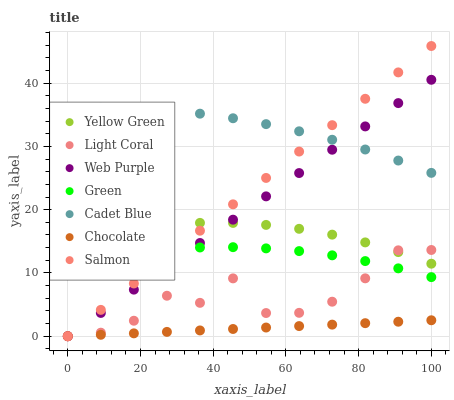Does Chocolate have the minimum area under the curve?
Answer yes or no. Yes. Does Cadet Blue have the maximum area under the curve?
Answer yes or no. Yes. Does Yellow Green have the minimum area under the curve?
Answer yes or no. No. Does Yellow Green have the maximum area under the curve?
Answer yes or no. No. Is Chocolate the smoothest?
Answer yes or no. Yes. Is Light Coral the roughest?
Answer yes or no. Yes. Is Yellow Green the smoothest?
Answer yes or no. No. Is Yellow Green the roughest?
Answer yes or no. No. Does Salmon have the lowest value?
Answer yes or no. Yes. Does Yellow Green have the lowest value?
Answer yes or no. No. Does Salmon have the highest value?
Answer yes or no. Yes. Does Yellow Green have the highest value?
Answer yes or no. No. Is Green less than Cadet Blue?
Answer yes or no. Yes. Is Green greater than Chocolate?
Answer yes or no. Yes. Does Light Coral intersect Chocolate?
Answer yes or no. Yes. Is Light Coral less than Chocolate?
Answer yes or no. No. Is Light Coral greater than Chocolate?
Answer yes or no. No. Does Green intersect Cadet Blue?
Answer yes or no. No. 